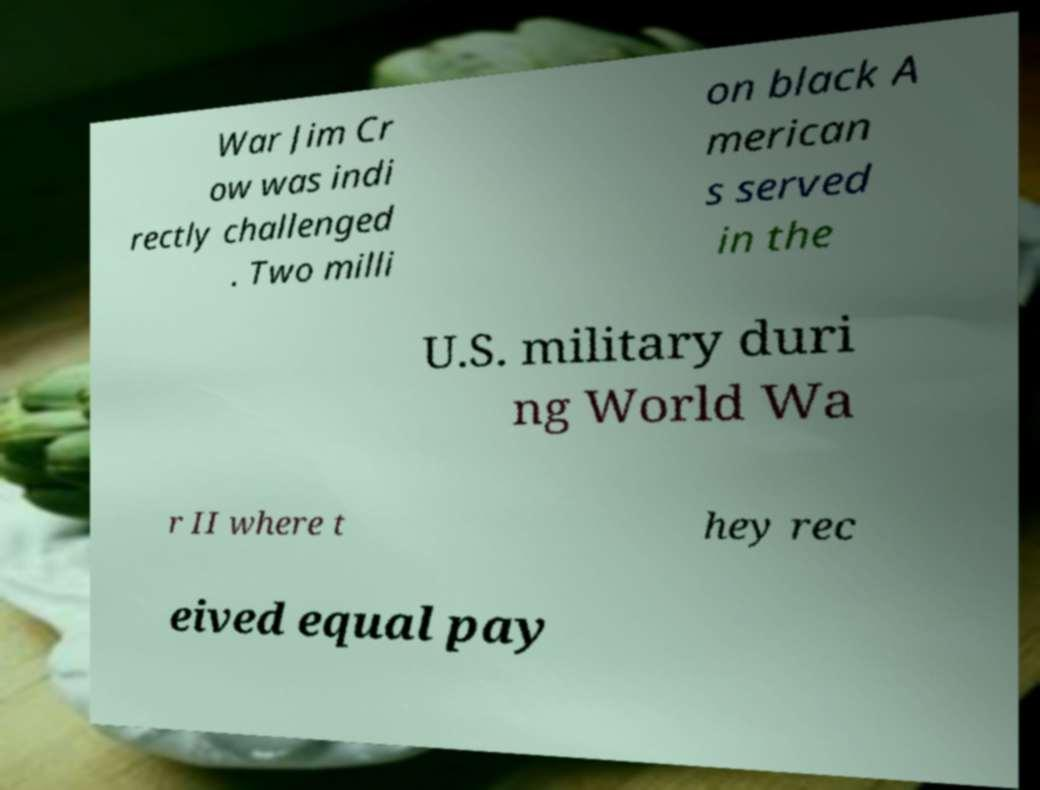I need the written content from this picture converted into text. Can you do that? War Jim Cr ow was indi rectly challenged . Two milli on black A merican s served in the U.S. military duri ng World Wa r II where t hey rec eived equal pay 